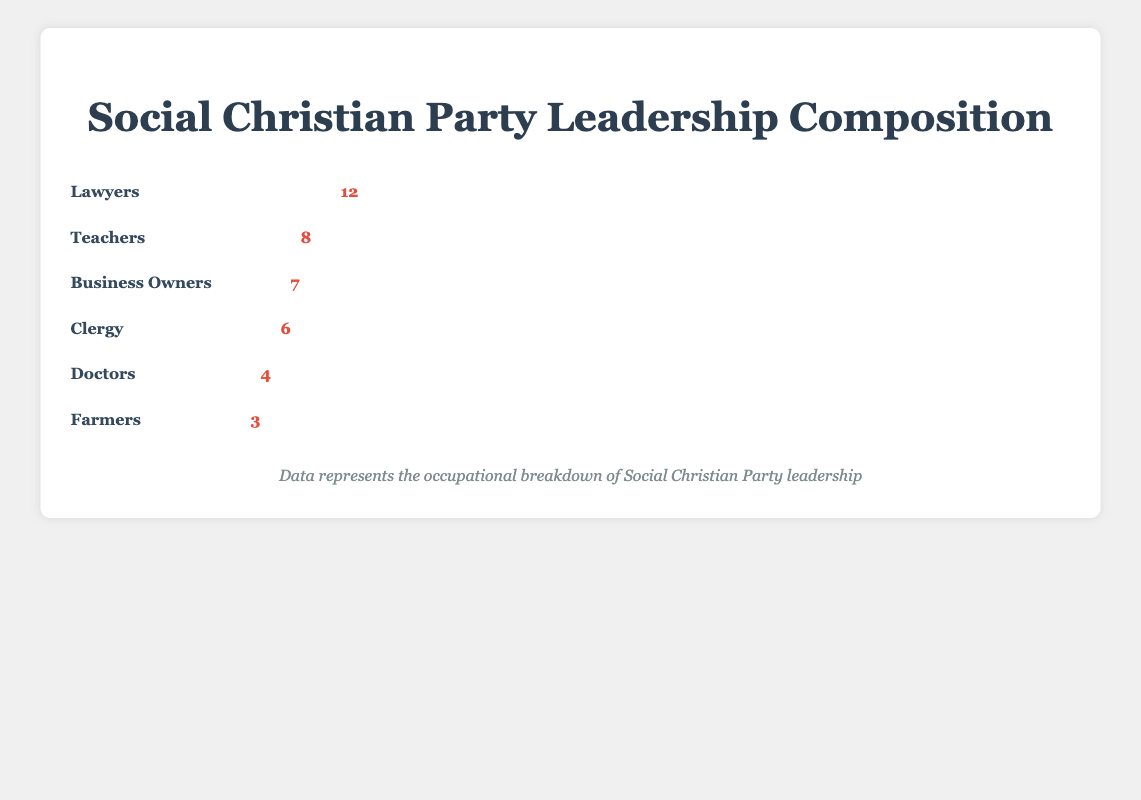What is the most common occupation within the party leadership? The figure shows the number of professionals from different occupations. By looking at the number of icons for each occupation, it is clear that "Lawyers" have the highest count with 12 icons.
Answer: Lawyers How many total occupations are represented in the party leadership? The figure displays various occupations under the leadership. By counting the number of distinct occupations listed, we have "Lawyers", "Teachers", "Business Owners", "Clergy", "Doctors", and "Farmers".
Answer: 6 How many more lawyers are there than farmers in the party leadership? According to the figure, lawyers have 12 icons and farmers have 3 icons. Subtracting the smaller value from the larger one gives the difference: 12 - 3 = 9.
Answer: 9 Which occupations have fewer than 5 representatives in the party leadership? Checking the counts for each occupation, we see that "Doctors" and "Farmers" are the ones with fewer than 5 representatives, with counts of 4 and 3 respectively.
Answer: Doctors, Farmers What is the total number of party leadership members represented in the figure? Adding up the counts for each occupation gives the total number of party leaders: 12 (Lawyers) + 8 (Teachers) + 7 (Business Owners) + 6 (Clergy) + 4 (Doctors) + 3 (Farmers). Total = 40.
Answer: 40 What is the combined count of teachers and business owners in the party leadership? The number of teachers is 8 and the number of business owners is 7. Adding these together: 8 + 7 = 15.
Answer: 15 Which occupations have exactly 6 representatives in the party leadership? By examining the figure, "Clergy" is the only occupation with a count of 6.
Answer: Clergy Between doctors and business owners, which group has fewer representatives? Doctors have 4 representatives, while business owners have 7. Comparing these counts, doctors have fewer representatives.
Answer: Doctors 